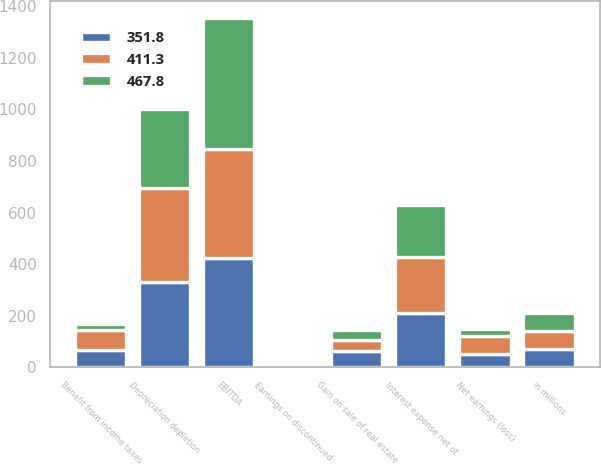Convert chart to OTSL. <chart><loc_0><loc_0><loc_500><loc_500><stacked_bar_chart><ecel><fcel>in millions<fcel>Net earnings (loss)<fcel>Benefit from income taxes<fcel>Interest expense net of<fcel>Earnings on discontinued<fcel>Depreciation depletion<fcel>EBITDA<fcel>Gain on sale of real estate<nl><fcel>467.8<fcel>70.8<fcel>24.4<fcel>24.5<fcel>201.7<fcel>3.6<fcel>307.1<fcel>505.1<fcel>36.8<nl><fcel>351.8<fcel>70.8<fcel>52.6<fcel>66.5<fcel>211.9<fcel>1.3<fcel>332<fcel>423.5<fcel>65.1<nl><fcel>411.3<fcel>70.8<fcel>70.8<fcel>78.5<fcel>217.3<fcel>4.5<fcel>361.7<fcel>425.2<fcel>42.1<nl></chart> 